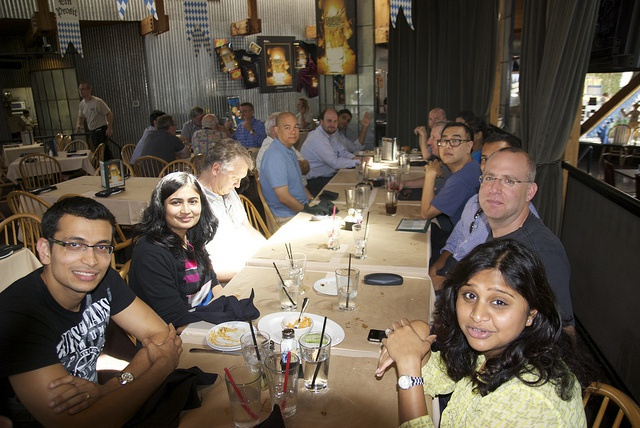Describe the objects in this image and their specific colors. I can see dining table in gray, tan, black, maroon, and lightgray tones, people in gray, black, and maroon tones, people in gray, black, khaki, and tan tones, dining table in gray, ivory, and tan tones, and people in gray, black, and maroon tones in this image. 